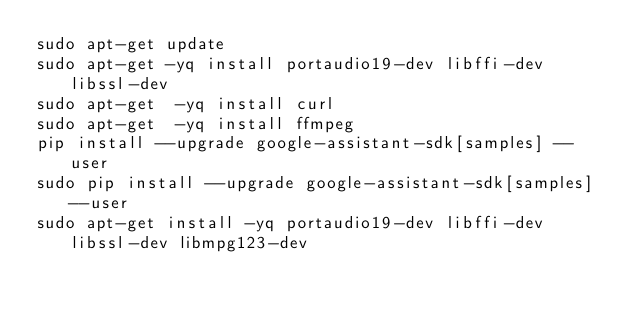Convert code to text. <code><loc_0><loc_0><loc_500><loc_500><_Bash_>sudo apt-get update
sudo apt-get -yq install portaudio19-dev libffi-dev libssl-dev
sudo apt-get  -yq install curl
sudo apt-get  -yq install ffmpeg
pip install --upgrade google-assistant-sdk[samples] --user
sudo pip install --upgrade google-assistant-sdk[samples] --user
sudo apt-get install -yq portaudio19-dev libffi-dev libssl-dev libmpg123-dev
</code> 